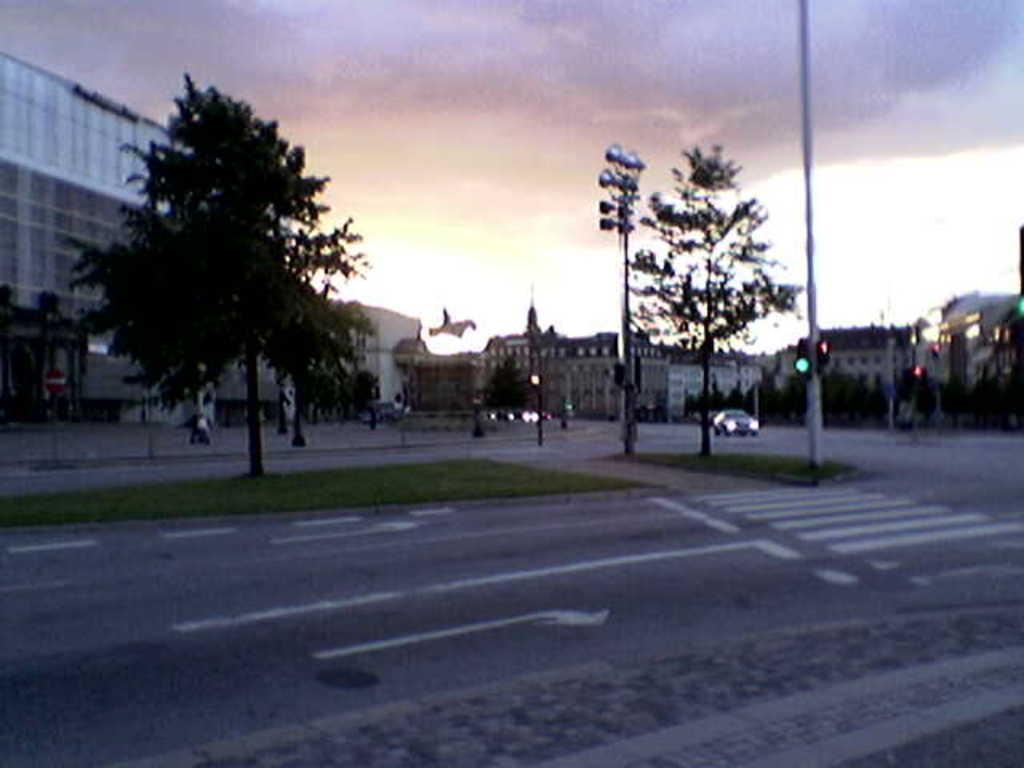Can you describe this image briefly? In this picture, we can see the road, vehicles, ground with garden, poles, trees, lights, building with windows, and the sky with clouds. 